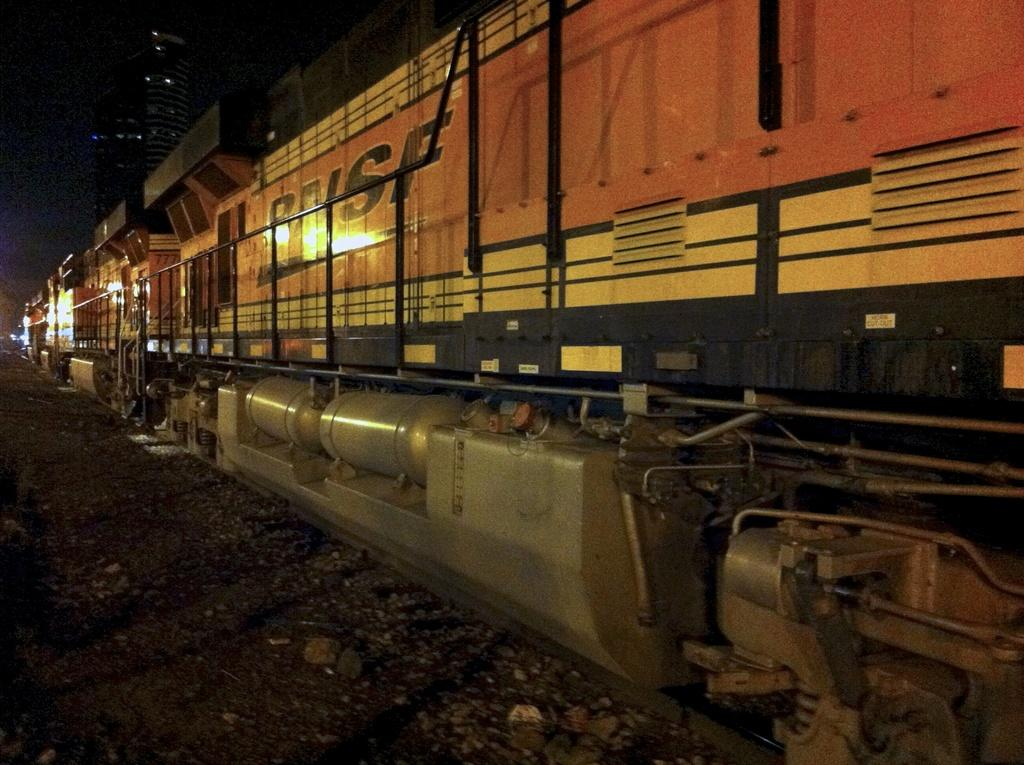What is the main subject of the image? The main subject of the image is a train. Where is the train located in the image? The train is on a railway track. What can be observed about the background of the image? The background of the image is dark. What type of ray is visible in the image? There is no ray present in the image; it features a train on a railway track with a dark background. 